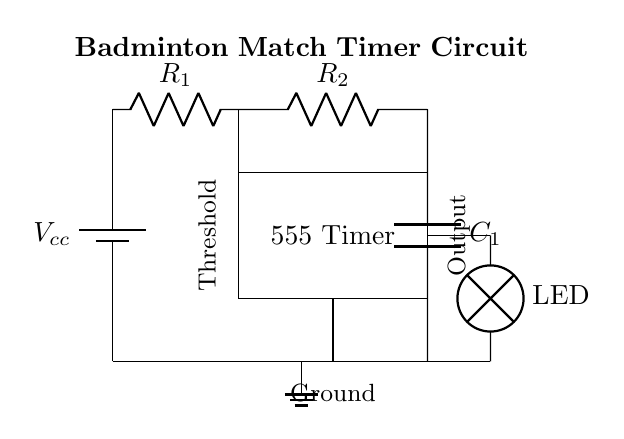What is the voltage source in this circuit? The voltage source is represented by a battery, labeled as Vcc, located at the top left of the circuit diagram.
Answer: Vcc What component is used as a timing element? The timing element in the circuit is the combination of resistors R1 and R2 along with capacitor C1, which determine the duration of the timer.
Answer: R1, R2, C1 What is the output component of the timer circuit? The output component is labeled as LED, which serves as an indicator to show the timer's operational status by lighting up.
Answer: LED What is the function of the 555 Timer IC? The 555 Timer IC manages the timing and output of the circuit, converting the voltage changes from the resistors and capacitor into a timed output signal.
Answer: Timer How are the resistors connected to the timer? Resistor R1 connects to the voltage source, while R2 connects from the output of the timer to the capacitor, facilitating the timing mechanism through their serial arrangement.
Answer: Series What needs to be connected to the ground for this circuit to work? The ground needs to connect the lower terminal of the LED and the common point at the bottom of the circuit to maintain a complete electrical path for the flow of current.
Answer: LED, ground 